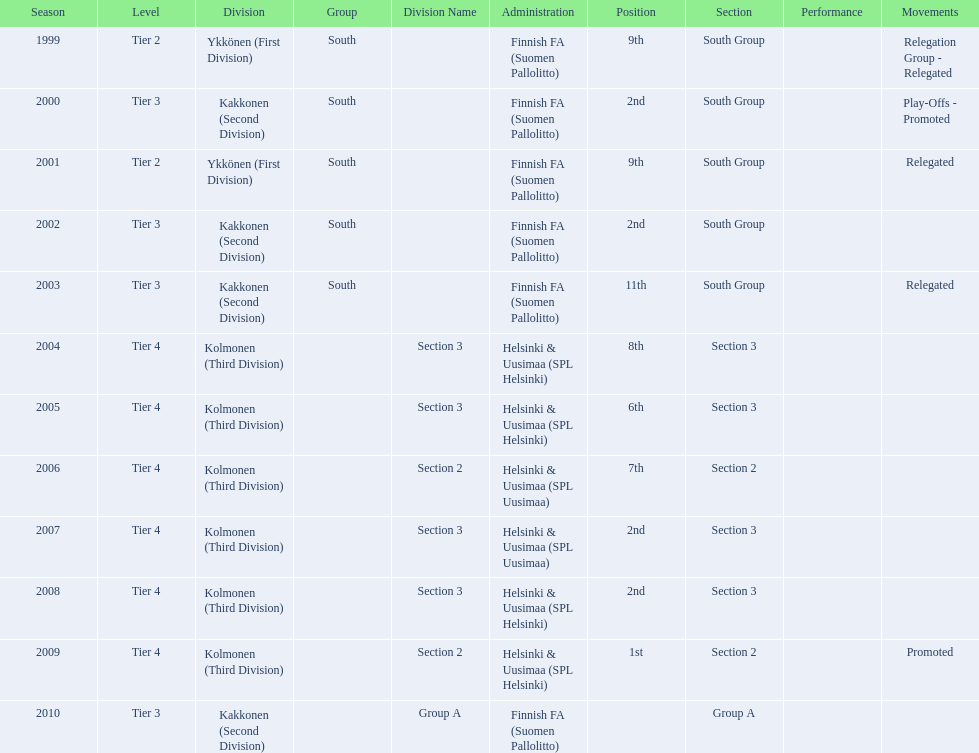How many times has this team been relegated? 3. Parse the table in full. {'header': ['Season', 'Level', 'Division', 'Group', 'Division Name', 'Administration', 'Position', 'Section', 'Performance', 'Movements'], 'rows': [['1999', 'Tier 2', 'Ykkönen (First Division)', 'South', '', 'Finnish FA (Suomen Pallolitto)', '9th', 'South Group', '', 'Relegation Group - Relegated'], ['2000', 'Tier 3', 'Kakkonen (Second Division)', 'South', '', 'Finnish FA (Suomen Pallolitto)', '2nd', 'South Group', '', 'Play-Offs - Promoted'], ['2001', 'Tier 2', 'Ykkönen (First Division)', 'South', '', 'Finnish FA (Suomen Pallolitto)', '9th', 'South Group', '', 'Relegated'], ['2002', 'Tier 3', 'Kakkonen (Second Division)', 'South', '', 'Finnish FA (Suomen Pallolitto)', '2nd', 'South Group', '', ''], ['2003', 'Tier 3', 'Kakkonen (Second Division)', 'South', '', 'Finnish FA (Suomen Pallolitto)', '11th', 'South Group', '', 'Relegated'], ['2004', 'Tier 4', 'Kolmonen (Third Division)', '', 'Section 3', 'Helsinki & Uusimaa (SPL Helsinki)', '8th', 'Section 3', '', ''], ['2005', 'Tier 4', 'Kolmonen (Third Division)', '', 'Section 3', 'Helsinki & Uusimaa (SPL Helsinki)', '6th', 'Section 3', '', ''], ['2006', 'Tier 4', 'Kolmonen (Third Division)', '', 'Section 2', 'Helsinki & Uusimaa (SPL Uusimaa)', '7th', 'Section 2', '', ''], ['2007', 'Tier 4', 'Kolmonen (Third Division)', '', 'Section 3', 'Helsinki & Uusimaa (SPL Uusimaa)', '2nd', 'Section 3', '', ''], ['2008', 'Tier 4', 'Kolmonen (Third Division)', '', 'Section 3', 'Helsinki & Uusimaa (SPL Helsinki)', '2nd', 'Section 3', '', ''], ['2009', 'Tier 4', 'Kolmonen (Third Division)', '', 'Section 2', 'Helsinki & Uusimaa (SPL Helsinki)', '1st', 'Section 2', '', 'Promoted'], ['2010', 'Tier 3', 'Kakkonen (Second Division)', '', 'Group A', 'Finnish FA (Suomen Pallolitto)', '', 'Group A', '', '']]} 